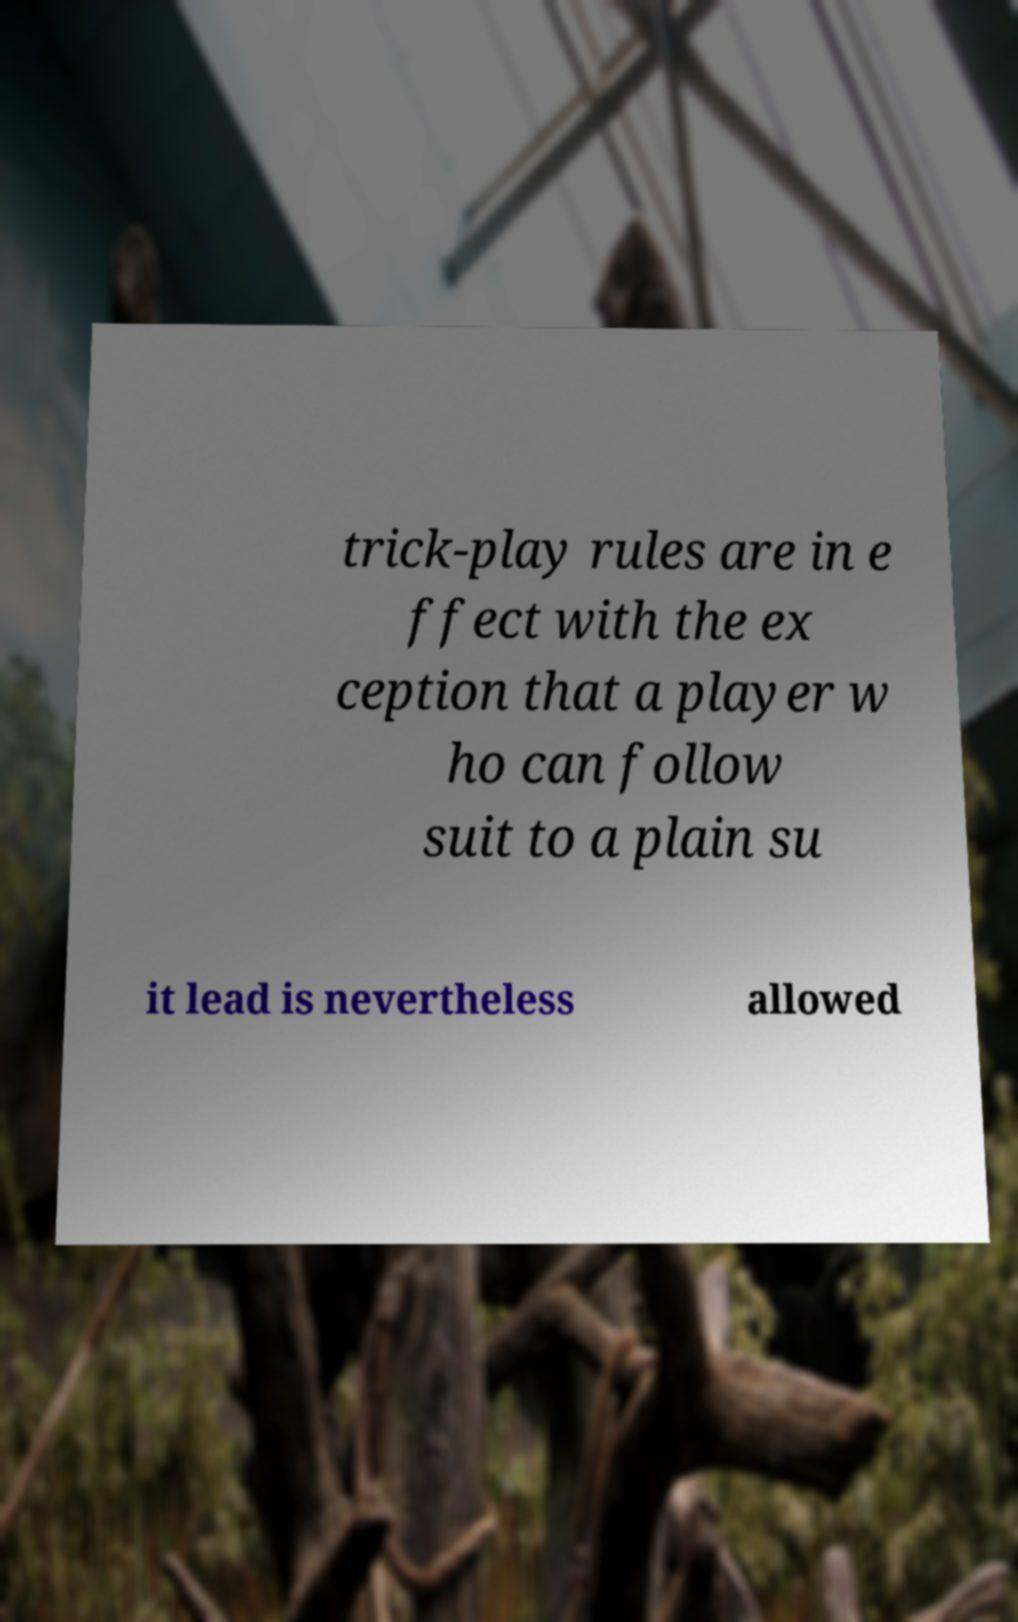Could you assist in decoding the text presented in this image and type it out clearly? trick-play rules are in e ffect with the ex ception that a player w ho can follow suit to a plain su it lead is nevertheless allowed 